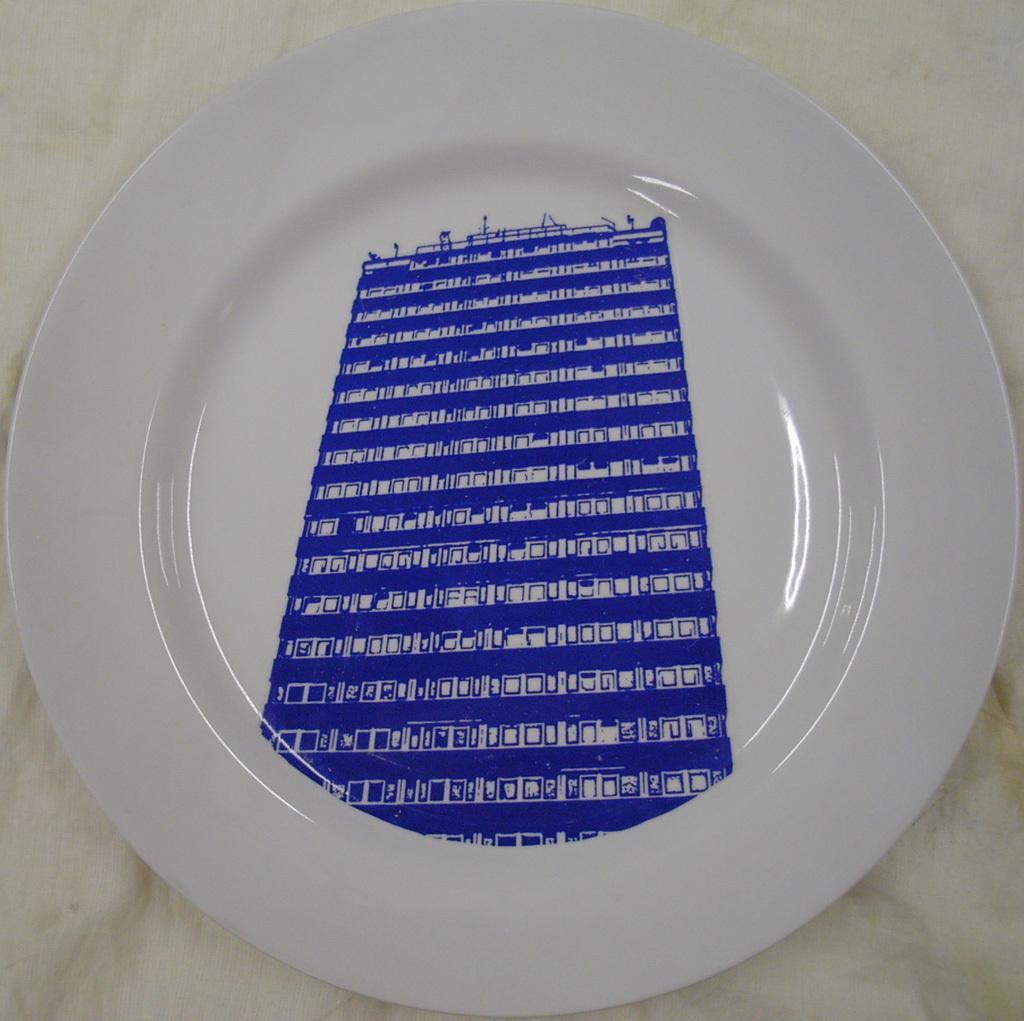Can you describe this image briefly? In the image there is a plate and there is a building image on the plate. 